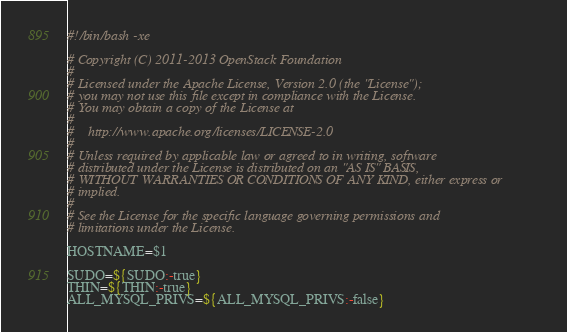<code> <loc_0><loc_0><loc_500><loc_500><_Bash_>#!/bin/bash -xe

# Copyright (C) 2011-2013 OpenStack Foundation
#
# Licensed under the Apache License, Version 2.0 (the "License");
# you may not use this file except in compliance with the License.
# You may obtain a copy of the License at
#
#    http://www.apache.org/licenses/LICENSE-2.0
#
# Unless required by applicable law or agreed to in writing, software
# distributed under the License is distributed on an "AS IS" BASIS,
# WITHOUT WARRANTIES OR CONDITIONS OF ANY KIND, either express or
# implied.
#
# See the License for the specific language governing permissions and
# limitations under the License.

HOSTNAME=$1

SUDO=${SUDO:-true}
THIN=${THIN:-true}
ALL_MYSQL_PRIVS=${ALL_MYSQL_PRIVS:-false}</code> 